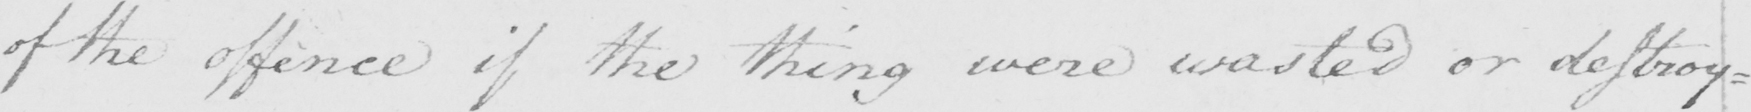Can you read and transcribe this handwriting? of the offence if the thing were wasted or destroy= 